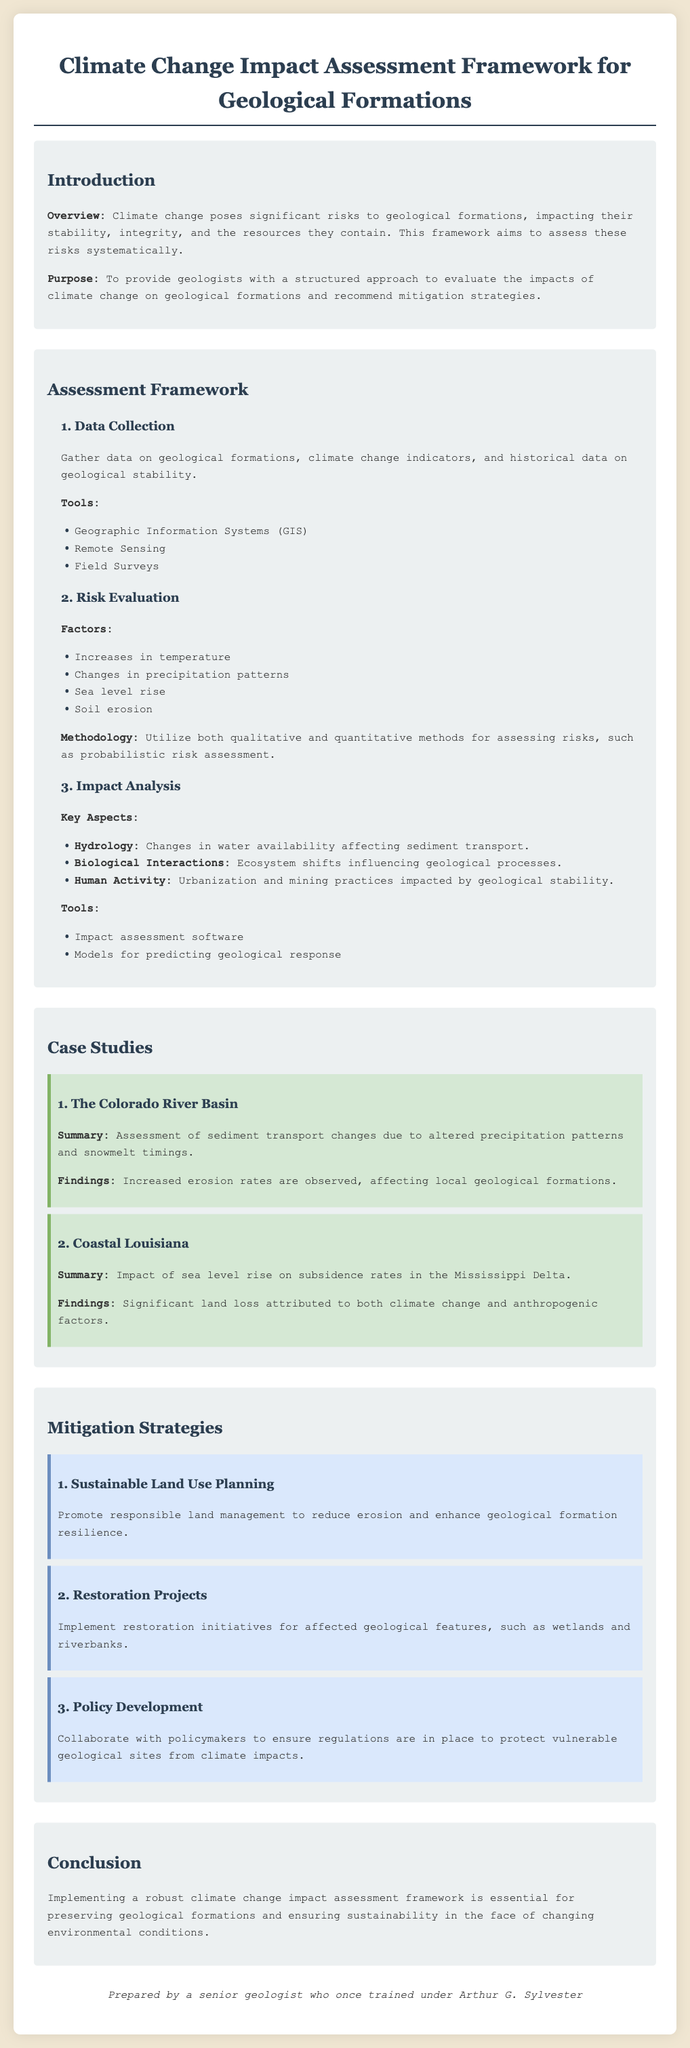What is the main purpose of the framework? The purpose of the framework is to provide geologists with a structured approach to evaluate the impacts of climate change on geological formations and recommend mitigation strategies.
Answer: To provide geologists with a structured approach What is the first step in the assessment framework? The first step in the assessment framework is data collection, where data on geological formations, climate change indicators, and historical data on geological stability is gathered.
Answer: Data Collection Which case study highlights the impact of sea level rise? The case study that highlights the impact of sea level rise is the one focused on Coastal Louisiana.
Answer: Coastal Louisiana What is one method used in risk evaluation? A method used in risk evaluation is probabilistic risk assessment.
Answer: Probabilistic risk assessment Name one mitigation strategy mentioned in the document. One mitigation strategy mentioned in the document is Sustainable Land Use Planning.
Answer: Sustainable Land Use Planning What factors are evaluated in the risk evaluation section? Factors evaluated in the risk evaluation section include increases in temperature, changes in precipitation patterns, sea level rise, and soil erosion.
Answer: Increases in temperature, changes in precipitation patterns, sea level rise, soil erosion How many case studies are presented in the document? There are two case studies presented in the document.
Answer: Two What text style is used for headings in the document? The text style used for headings in the document is 'Georgia', serif.
Answer: 'Georgia', serif What is the background color of the document? The background color of the document is #f0e6d2.
Answer: #f0e6d2 